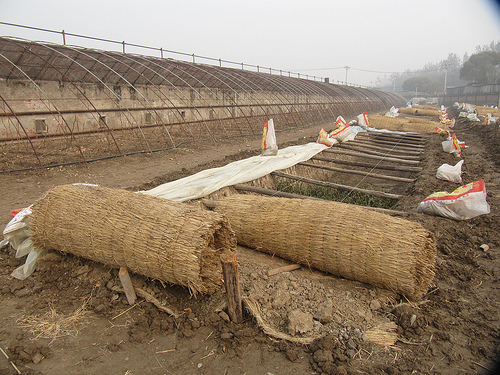<image>
Is there a grass in front of the bag? Yes. The grass is positioned in front of the bag, appearing closer to the camera viewpoint. 